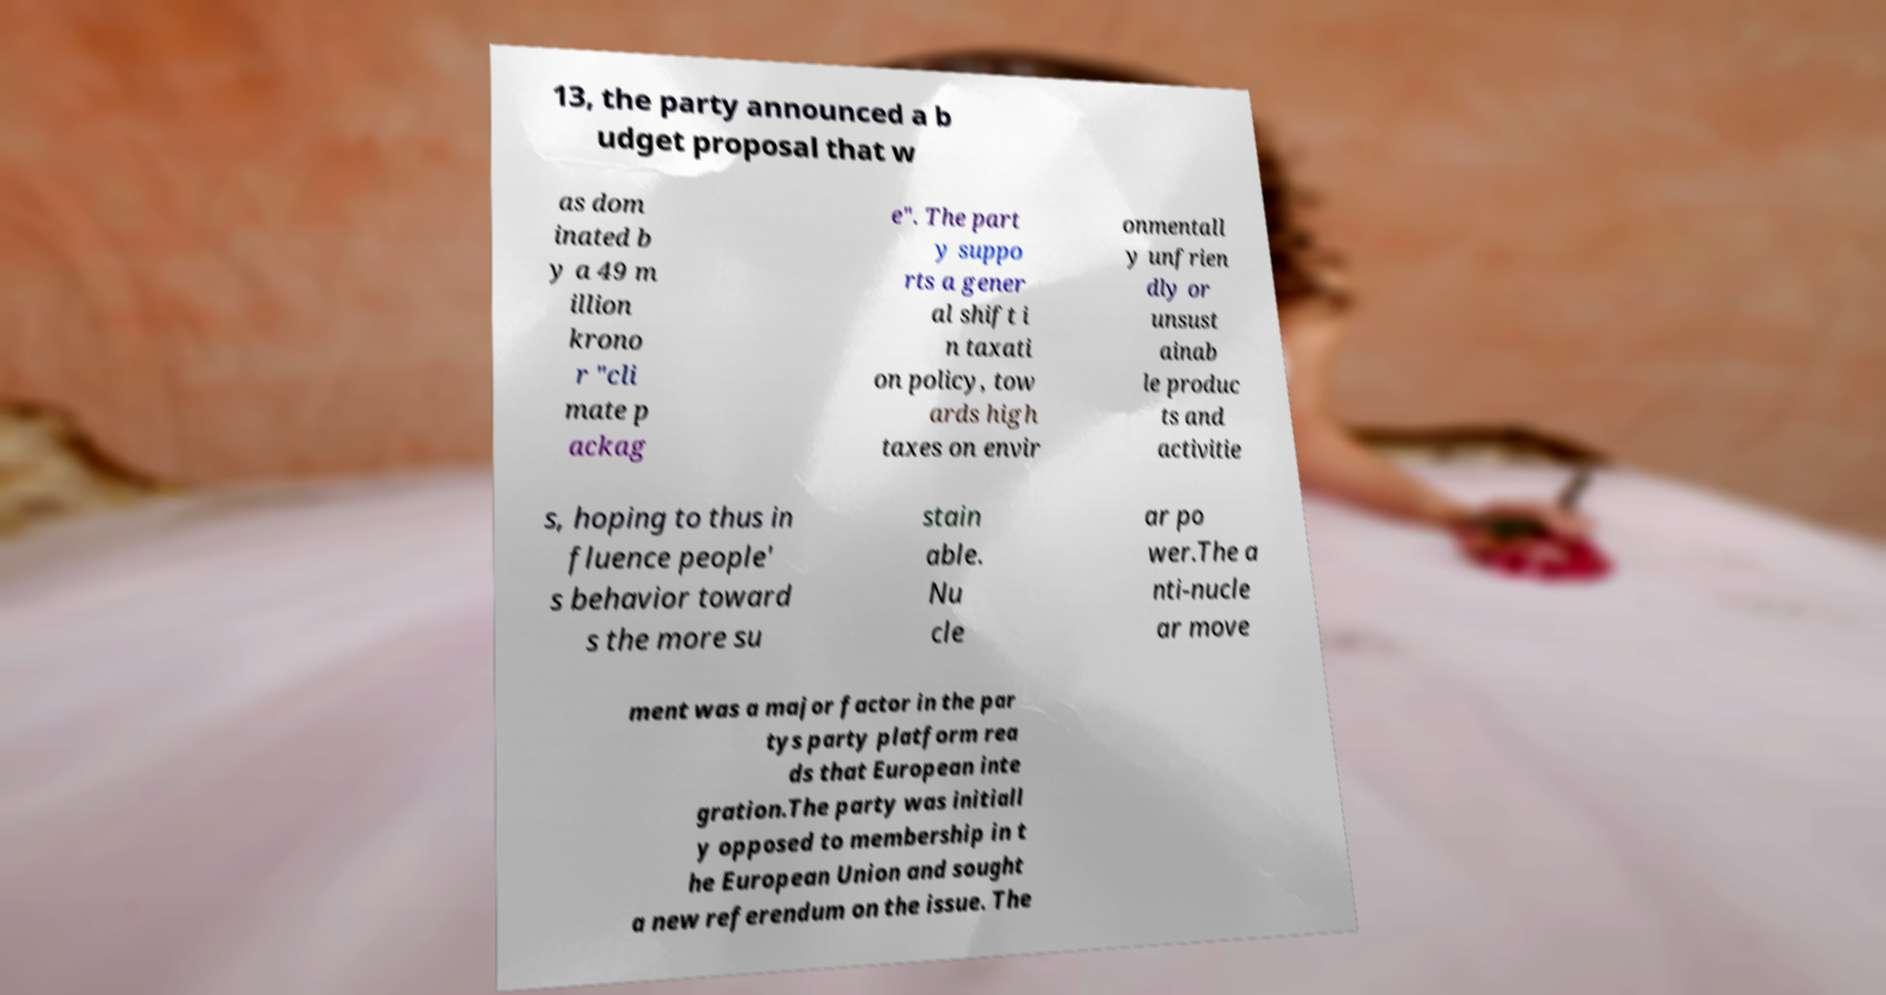Could you assist in decoding the text presented in this image and type it out clearly? 13, the party announced a b udget proposal that w as dom inated b y a 49 m illion krono r "cli mate p ackag e". The part y suppo rts a gener al shift i n taxati on policy, tow ards high taxes on envir onmentall y unfrien dly or unsust ainab le produc ts and activitie s, hoping to thus in fluence people' s behavior toward s the more su stain able. Nu cle ar po wer.The a nti-nucle ar move ment was a major factor in the par tys party platform rea ds that European inte gration.The party was initiall y opposed to membership in t he European Union and sought a new referendum on the issue. The 